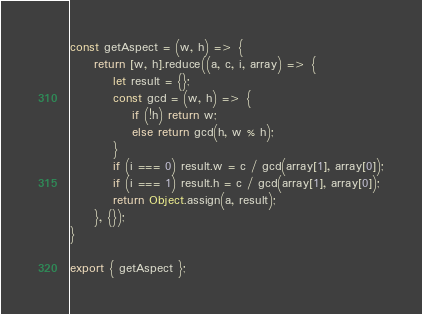Convert code to text. <code><loc_0><loc_0><loc_500><loc_500><_JavaScript_>const getAspect = (w, h) => {
     return [w, h].reduce((a, c, i, array) => {
         let result = {};
         const gcd = (w, h) => {
             if (!h) return w;
             else return gcd(h, w % h);
         }
         if (i === 0) result.w = c / gcd(array[1], array[0]);
         if (i === 1) result.h = c / gcd(array[1], array[0]);
         return Object.assign(a, result);
     }, {});
}

export { getAspect };</code> 